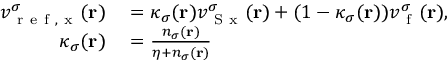Convert formula to latex. <formula><loc_0><loc_0><loc_500><loc_500>\begin{array} { r l } { v _ { r e f , x } ^ { \sigma } ( r ) } & = \kappa _ { \sigma } ( r ) v _ { S x } ^ { \sigma } ( r ) + ( 1 - \kappa _ { \sigma } ( r ) ) v _ { f } ^ { \sigma } ( r ) , } \\ { \kappa _ { \sigma } ( r ) } & = \frac { n _ { \sigma } ( r ) } { \eta + n _ { \sigma } ( r ) } } \end{array}</formula> 